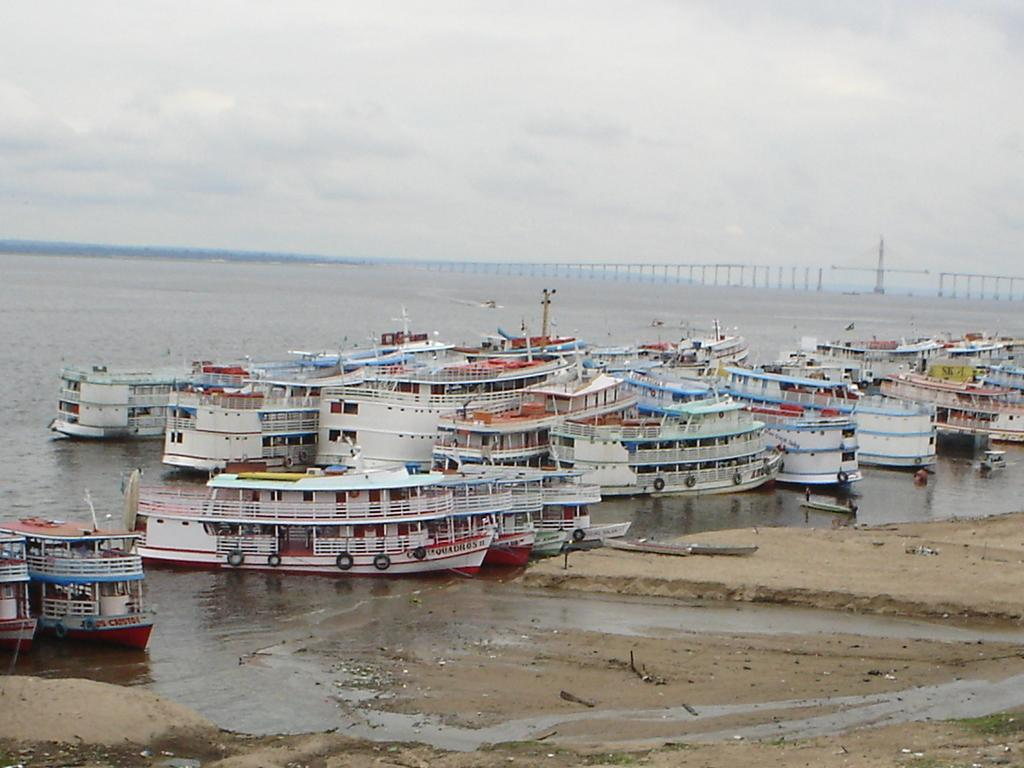What type of vehicles can be seen in the image? There are boats in the image. What is the primary element surrounding the boats? There is water visible in the image. What type of barrier is present in the image? There is a fence in the image. What type of terrain is visible in the image? There is sand in the image. What is visible above the boats and water? The sky is visible in the image. What type of business is being conducted in the middle of the image? There is no business activity present in the image; it features boats, water, a fence, sand, and the sky. 